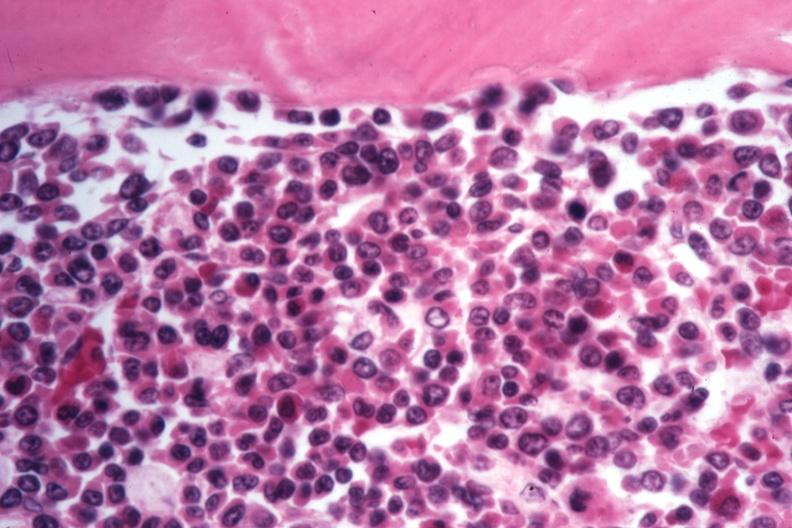what is present?
Answer the question using a single word or phrase. Hematologic 